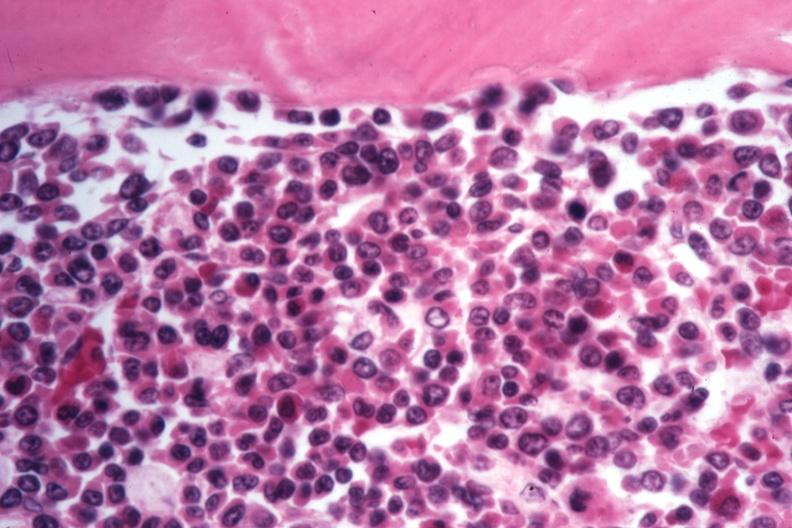what is present?
Answer the question using a single word or phrase. Hematologic 